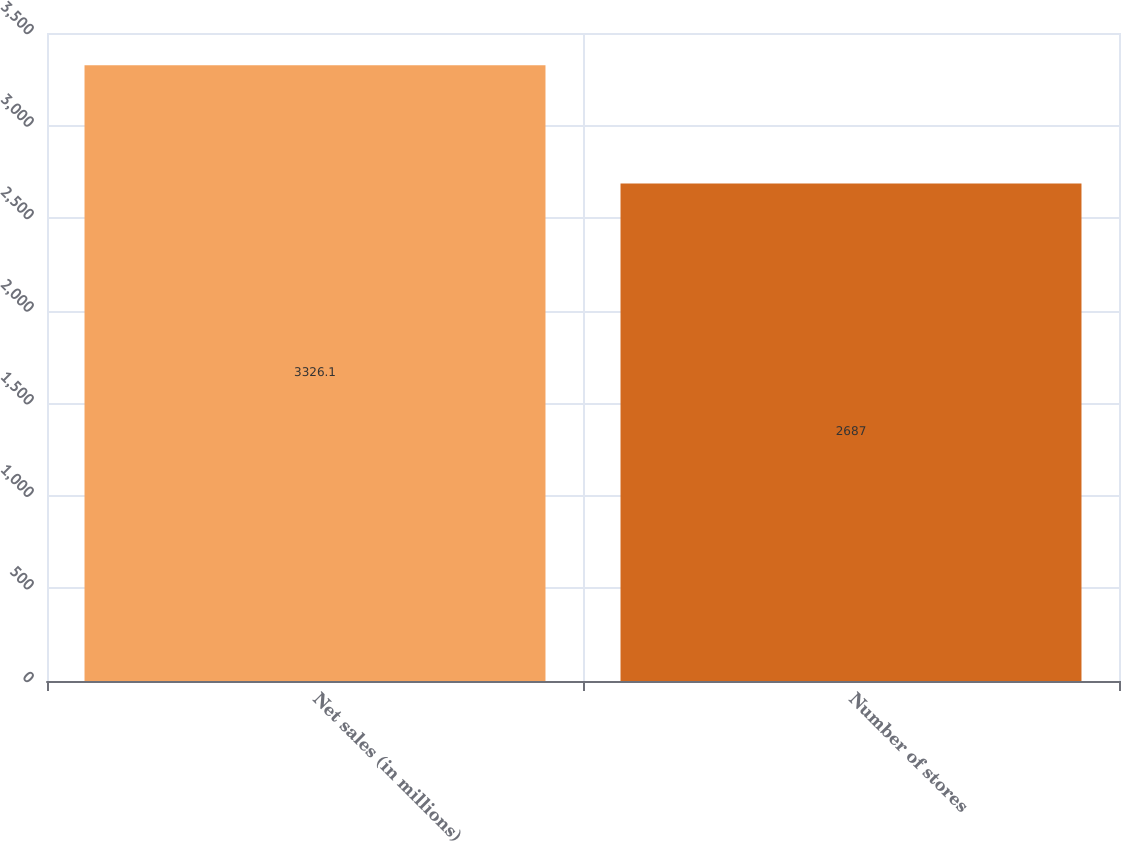Convert chart. <chart><loc_0><loc_0><loc_500><loc_500><bar_chart><fcel>Net sales (in millions)<fcel>Number of stores<nl><fcel>3326.1<fcel>2687<nl></chart> 